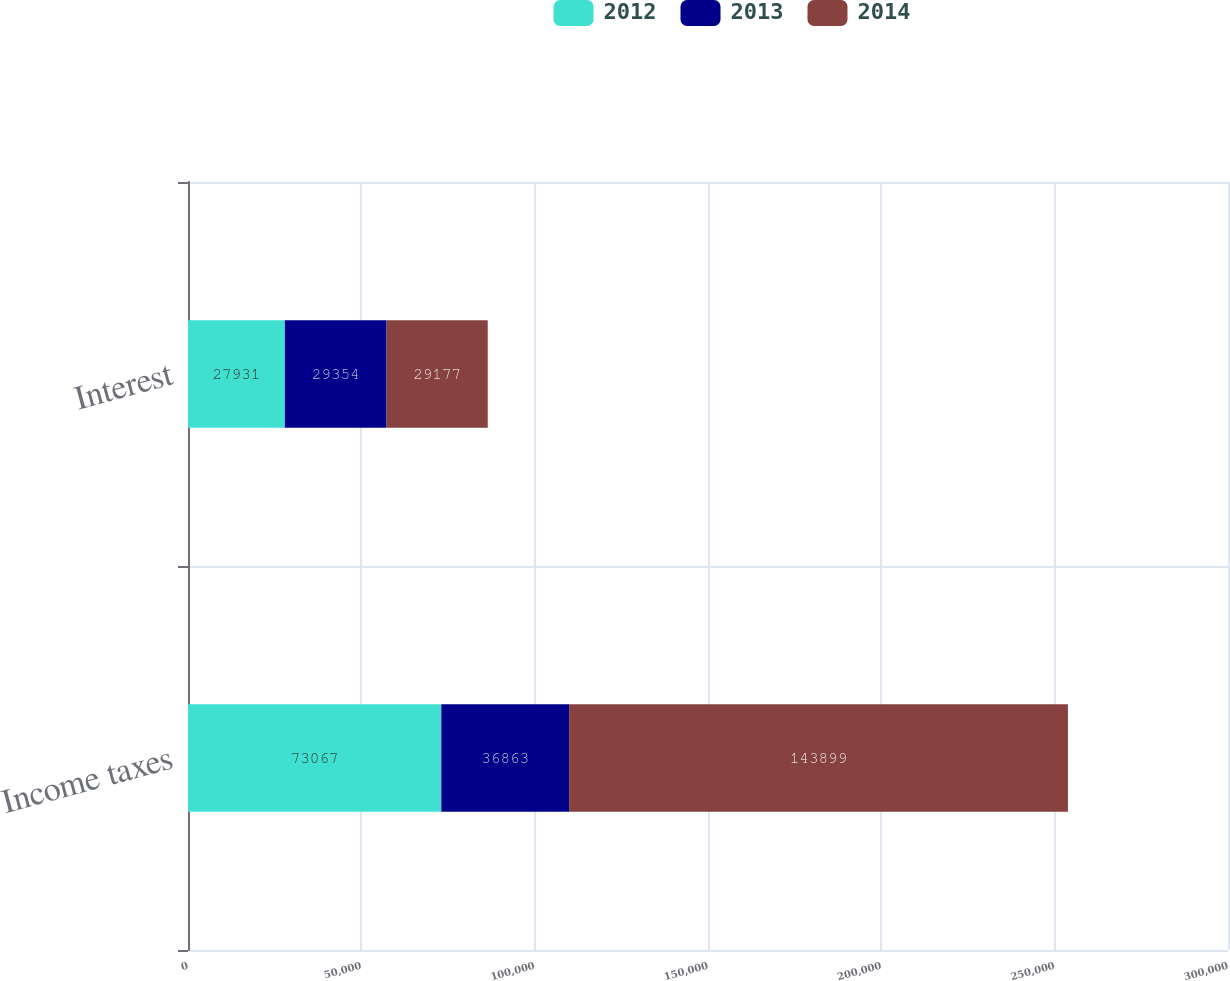Convert chart to OTSL. <chart><loc_0><loc_0><loc_500><loc_500><stacked_bar_chart><ecel><fcel>Income taxes<fcel>Interest<nl><fcel>2012<fcel>73067<fcel>27931<nl><fcel>2013<fcel>36863<fcel>29354<nl><fcel>2014<fcel>143899<fcel>29177<nl></chart> 